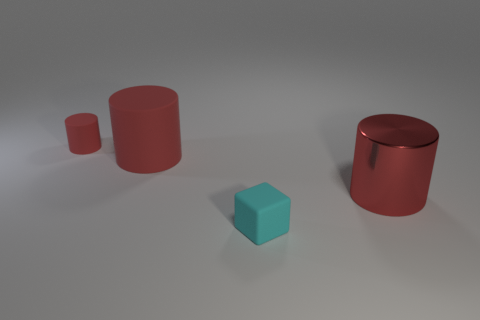How many large red metal objects are there?
Give a very brief answer. 1. Does the metal cylinder have the same color as the large matte thing?
Give a very brief answer. Yes. What is the color of the cylinder that is both left of the metallic cylinder and to the right of the small red cylinder?
Provide a short and direct response. Red. There is a cyan matte thing; are there any objects to the left of it?
Provide a short and direct response. Yes. How many red matte things are behind the red matte cylinder in front of the tiny red thing?
Provide a succinct answer. 1. What size is the other cylinder that is the same material as the small red cylinder?
Provide a short and direct response. Large. How big is the metal object?
Your response must be concise. Large. Do the tiny cyan object and the tiny cylinder have the same material?
Give a very brief answer. Yes. What number of cylinders are cyan rubber objects or large brown matte things?
Ensure brevity in your answer.  0. What is the color of the tiny object in front of the small matte thing on the left side of the tiny matte cube?
Your answer should be very brief. Cyan. 